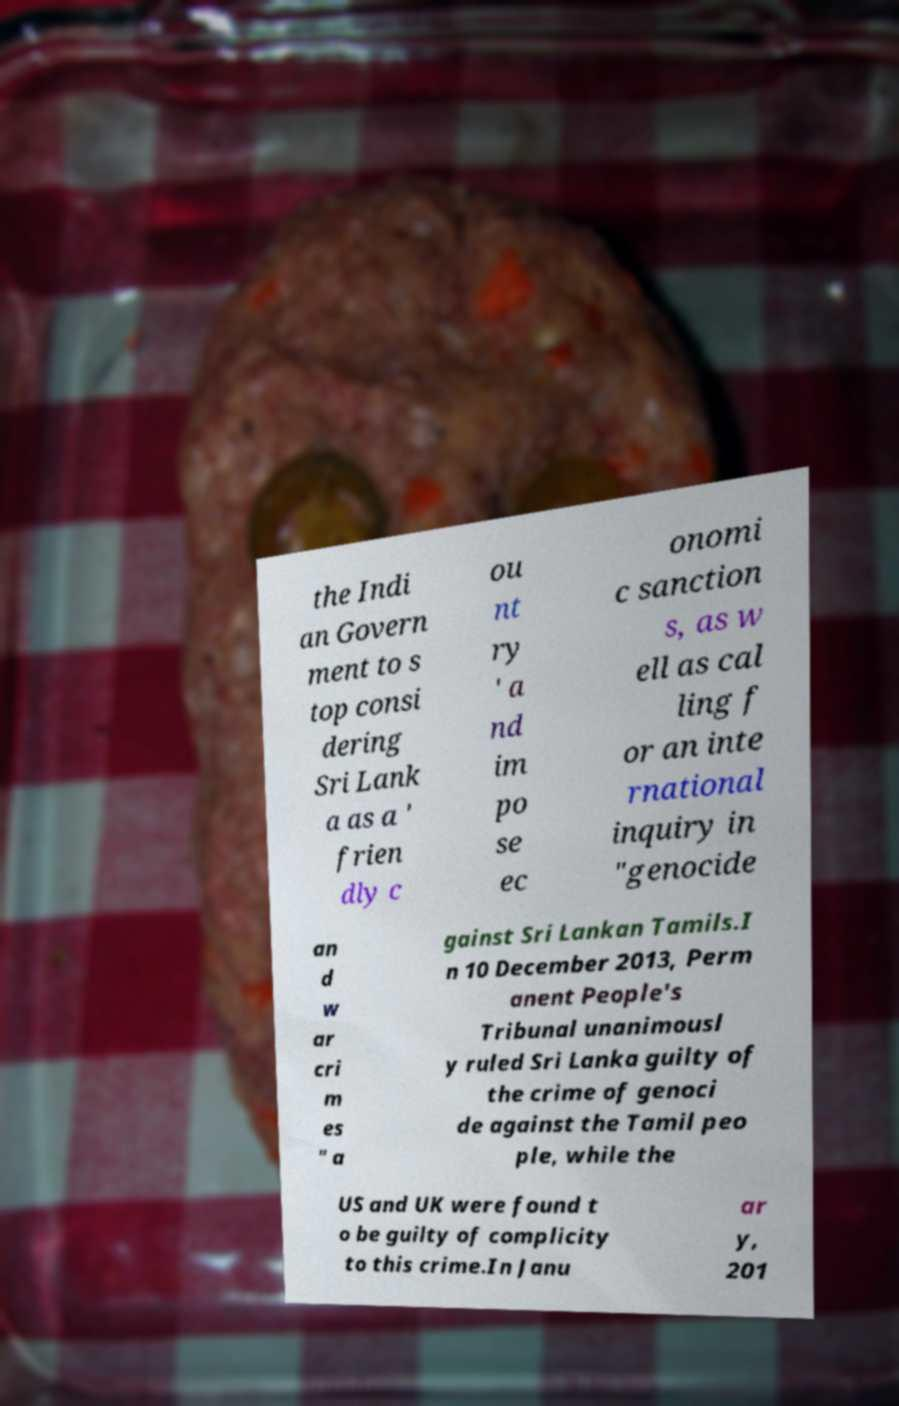There's text embedded in this image that I need extracted. Can you transcribe it verbatim? the Indi an Govern ment to s top consi dering Sri Lank a as a ' frien dly c ou nt ry ' a nd im po se ec onomi c sanction s, as w ell as cal ling f or an inte rnational inquiry in "genocide an d w ar cri m es " a gainst Sri Lankan Tamils.I n 10 December 2013, Perm anent People's Tribunal unanimousl y ruled Sri Lanka guilty of the crime of genoci de against the Tamil peo ple, while the US and UK were found t o be guilty of complicity to this crime.In Janu ar y, 201 